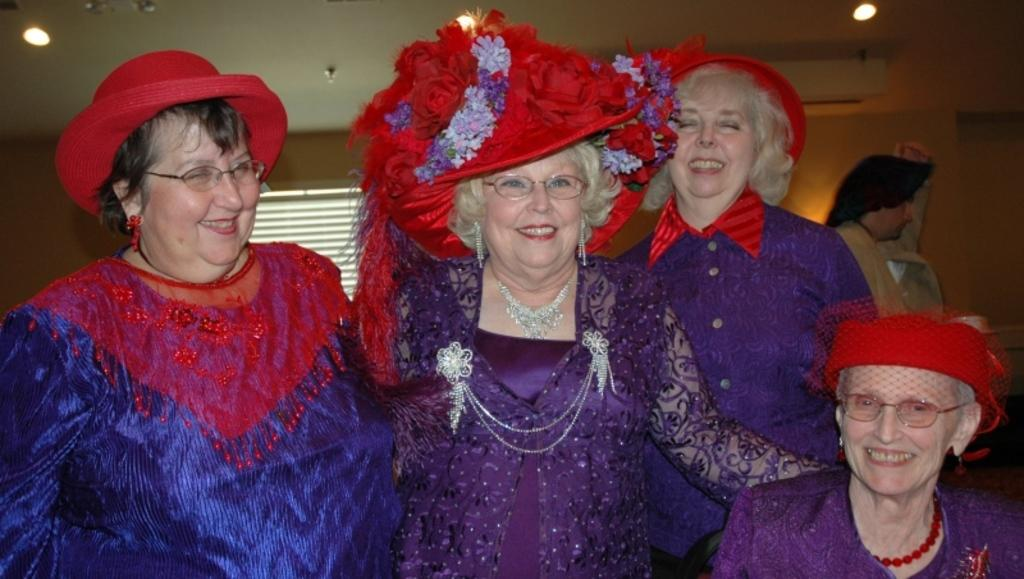How many people are in the image? There are four persons in the image. What is the facial expression of the people in the image? The four persons are smiling. What can be seen in the background of the image? There is a wall and lights in the background of the image. Are there any other people visible in the image? Yes, there is another person in the background of the image. What type of air is being circulated in the image? There is no information about air circulation in the image. What kind of bread is being served to the people in the image? There is no bread present in the image. 